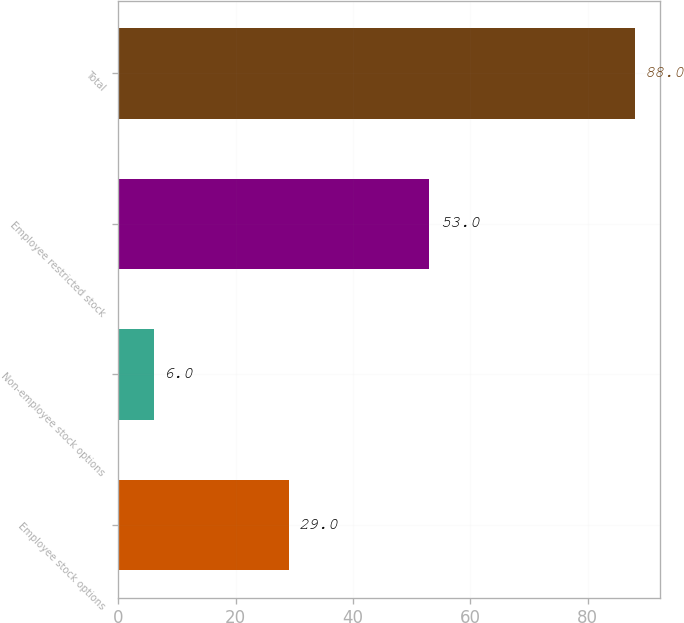Convert chart to OTSL. <chart><loc_0><loc_0><loc_500><loc_500><bar_chart><fcel>Employee stock options<fcel>Non-employee stock options<fcel>Employee restricted stock<fcel>Total<nl><fcel>29<fcel>6<fcel>53<fcel>88<nl></chart> 